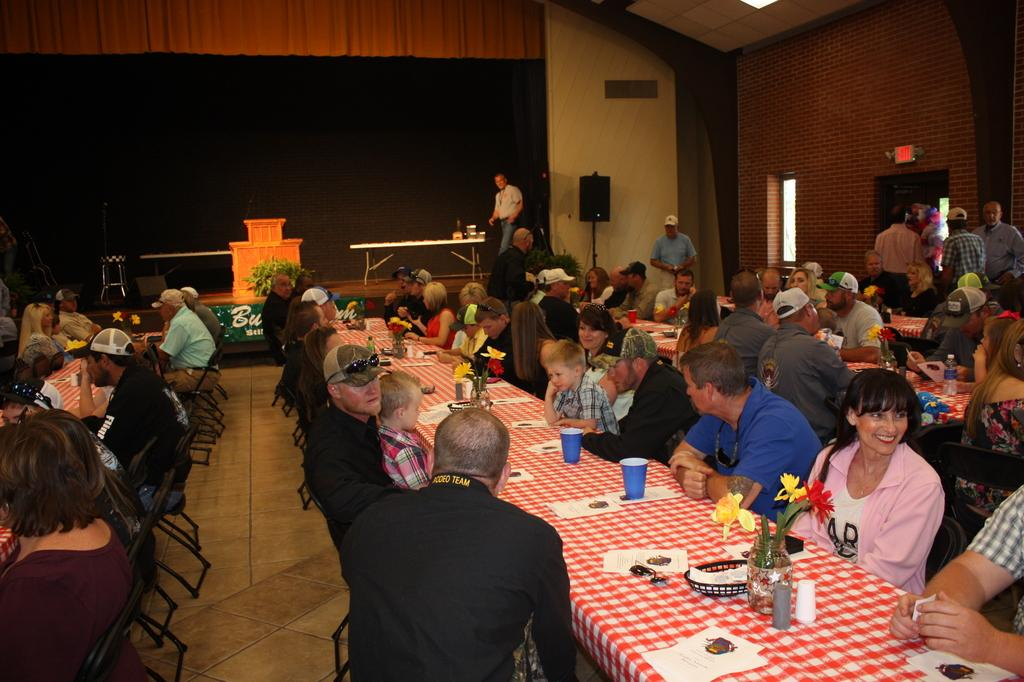What are the people in the image doing? There is a group of people sitting in chairs in the image. What is in front of the group of people? There is a table in front of the group of people. What can be seen on the table? The table has a cup, a paper, and a flower vase on it. What is the color of the background in the image? The background of the image is black in color. What type of bean is being served at the attraction in the image? There is no bean or attraction present in the image; it features a group of people sitting in chairs with a table in front of them. 